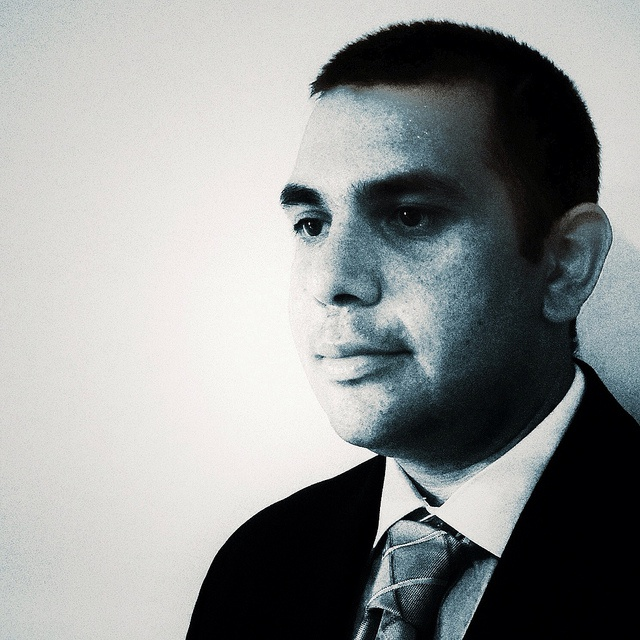Describe the objects in this image and their specific colors. I can see people in lightgray, black, gray, and darkgray tones and tie in lightgray, black, gray, darkgray, and blue tones in this image. 